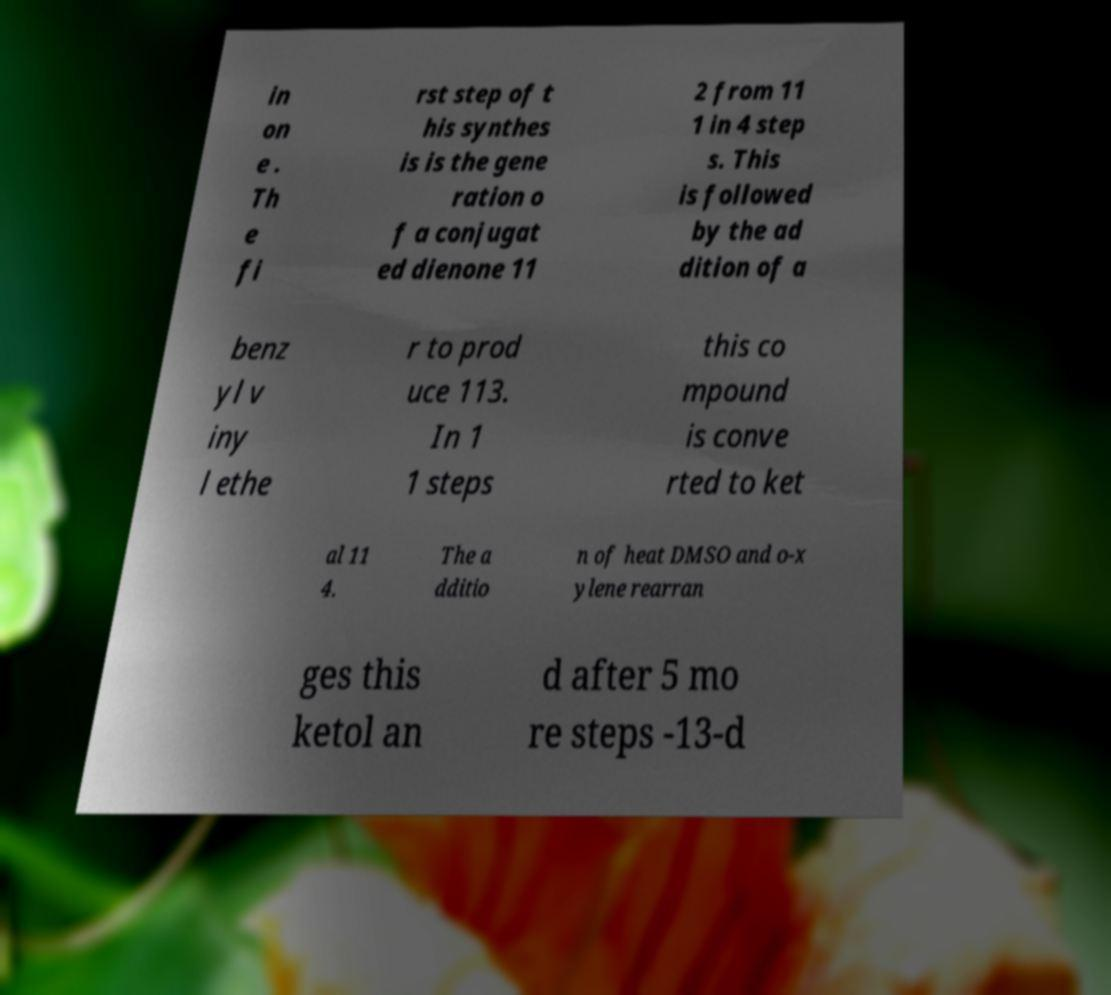Can you read and provide the text displayed in the image?This photo seems to have some interesting text. Can you extract and type it out for me? in on e . Th e fi rst step of t his synthes is is the gene ration o f a conjugat ed dienone 11 2 from 11 1 in 4 step s. This is followed by the ad dition of a benz yl v iny l ethe r to prod uce 113. In 1 1 steps this co mpound is conve rted to ket al 11 4. The a dditio n of heat DMSO and o-x ylene rearran ges this ketol an d after 5 mo re steps -13-d 